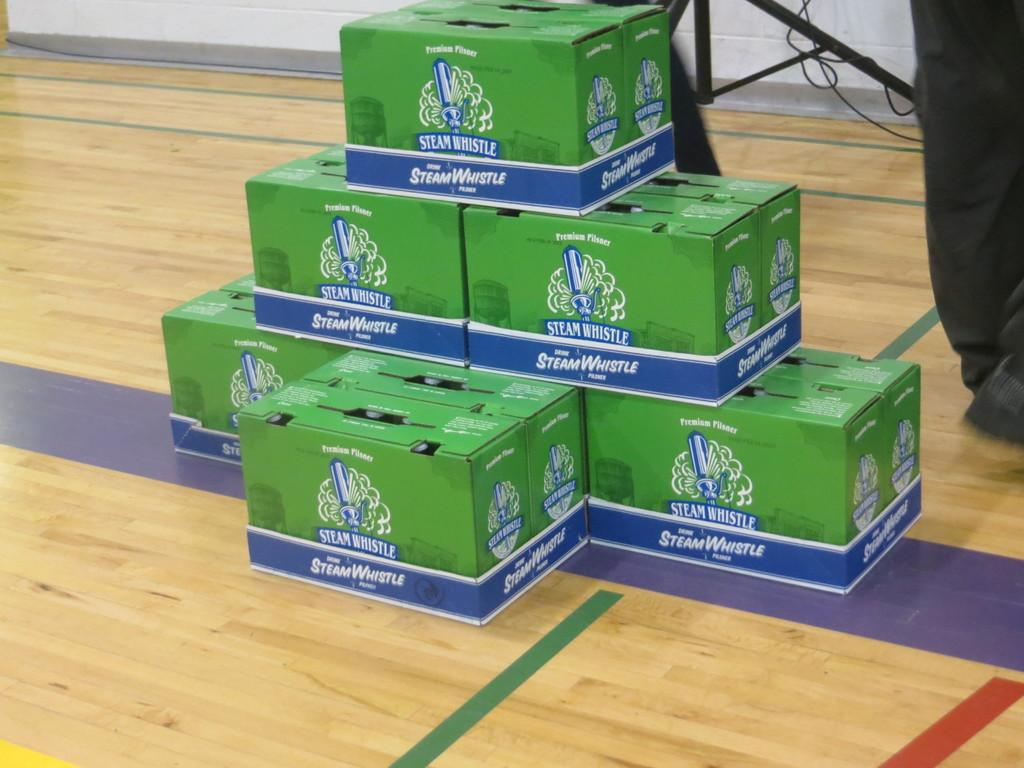<image>
Summarize the visual content of the image. 6 boxes of steam whistle beer on the floor 